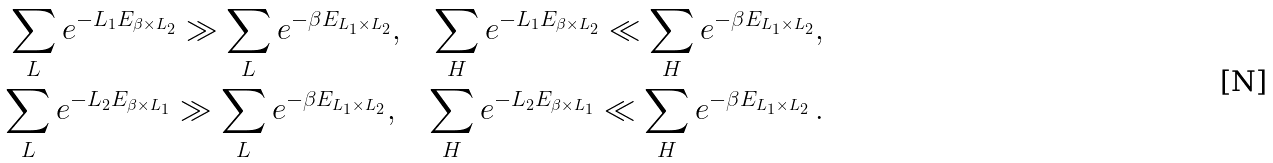<formula> <loc_0><loc_0><loc_500><loc_500>\sum _ { L } e ^ { - L _ { 1 } E _ { \beta \times L _ { 2 } } } \gg \sum _ { L } e ^ { - \beta E _ { L _ { 1 } \times L _ { 2 } } } , \quad \sum _ { H } e ^ { - L _ { 1 } E _ { \beta \times L _ { 2 } } } \ll \sum _ { H } e ^ { - \beta E _ { L _ { 1 } \times L _ { 2 } } } , \\ \sum _ { L } e ^ { - L _ { 2 } E _ { \beta \times L _ { 1 } } } \gg \sum _ { L } e ^ { - \beta E _ { L _ { 1 } \times L _ { 2 } } } , \quad \sum _ { H } e ^ { - L _ { 2 } E _ { \beta \times L _ { 1 } } } \ll \sum _ { H } e ^ { - \beta E _ { L _ { 1 } \times L _ { 2 } } } \, .</formula> 